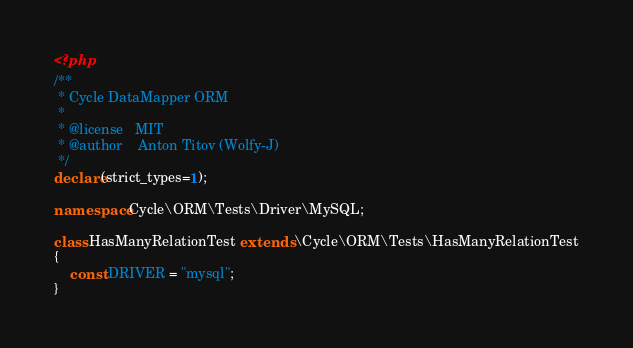Convert code to text. <code><loc_0><loc_0><loc_500><loc_500><_PHP_><?php
/**
 * Cycle DataMapper ORM
 *
 * @license   MIT
 * @author    Anton Titov (Wolfy-J)
 */
declare(strict_types=1);

namespace Cycle\ORM\Tests\Driver\MySQL;

class HasManyRelationTest extends \Cycle\ORM\Tests\HasManyRelationTest
{
    const DRIVER = "mysql";
}
</code> 